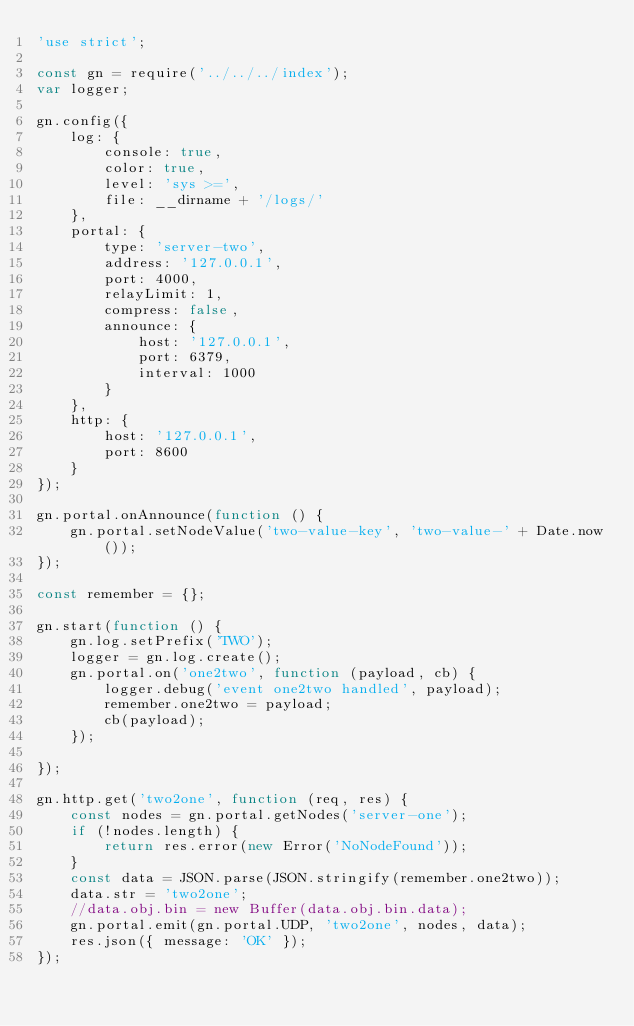Convert code to text. <code><loc_0><loc_0><loc_500><loc_500><_JavaScript_>'use strict';

const gn = require('../../../index');
var logger;

gn.config({
    log: {
        console: true,
        color: true,
        level: 'sys >=',
        file: __dirname + '/logs/'
    },
    portal: {
        type: 'server-two',
        address: '127.0.0.1',
        port: 4000,
        relayLimit: 1,
        compress: false,
        announce: {
            host: '127.0.0.1',
            port: 6379,
            interval: 1000
        }
    },
    http: {
        host: '127.0.0.1',
        port: 8600
    }
});

gn.portal.onAnnounce(function () {
    gn.portal.setNodeValue('two-value-key', 'two-value-' + Date.now());
});

const remember = {};

gn.start(function () {
    gn.log.setPrefix('TWO');
    logger = gn.log.create();
    gn.portal.on('one2two', function (payload, cb) {
        logger.debug('event one2two handled', payload);
        remember.one2two = payload;
        cb(payload);
    });

});

gn.http.get('two2one', function (req, res) {
    const nodes = gn.portal.getNodes('server-one');
    if (!nodes.length) {
        return res.error(new Error('NoNodeFound'));
    }
    const data = JSON.parse(JSON.stringify(remember.one2two));
    data.str = 'two2one';
    //data.obj.bin = new Buffer(data.obj.bin.data);
    gn.portal.emit(gn.portal.UDP, 'two2one', nodes, data);
    res.json({ message: 'OK' });
});

</code> 